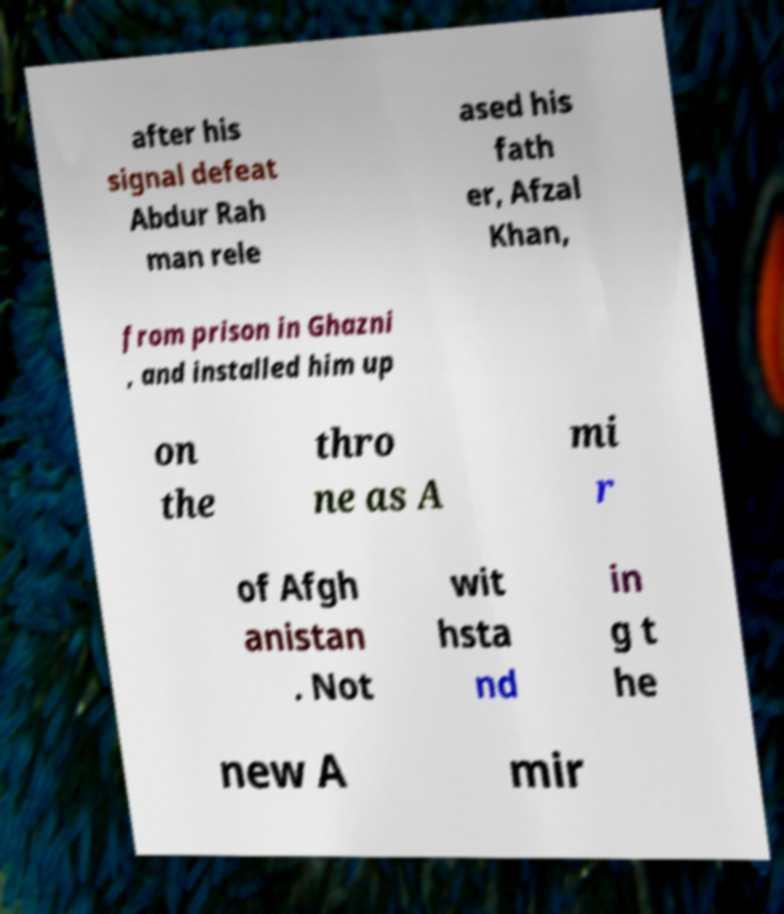Can you accurately transcribe the text from the provided image for me? after his signal defeat Abdur Rah man rele ased his fath er, Afzal Khan, from prison in Ghazni , and installed him up on the thro ne as A mi r of Afgh anistan . Not wit hsta nd in g t he new A mir 